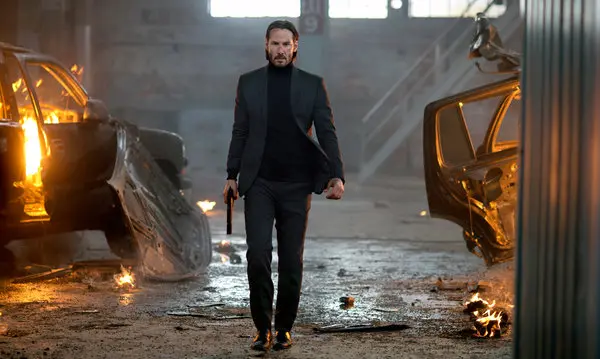What is happening in the background? In the background, the warehouse appears to be in complete disarray, with burning cars adding to the chaotic scene. The dim lighting and shadows play a crucial role in creating a tense atmosphere. The flickering flames from the cars emphasize the destruction and hint at a recent or ongoing conflict. This setting serves as a dramatic backdrop, heightening the stakes for the character in the foreground. 